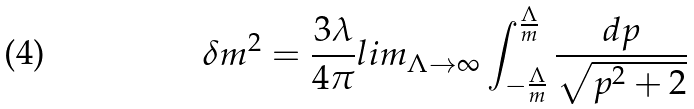Convert formula to latex. <formula><loc_0><loc_0><loc_500><loc_500>\delta m ^ { 2 } = \frac { 3 \lambda } { 4 \pi } l i m _ { \Lambda \rightarrow \infty } \int _ { - \frac { \Lambda } { m } } ^ { \frac { \Lambda } { m } } \frac { d p } { \sqrt { p ^ { 2 } + 2 } }</formula> 